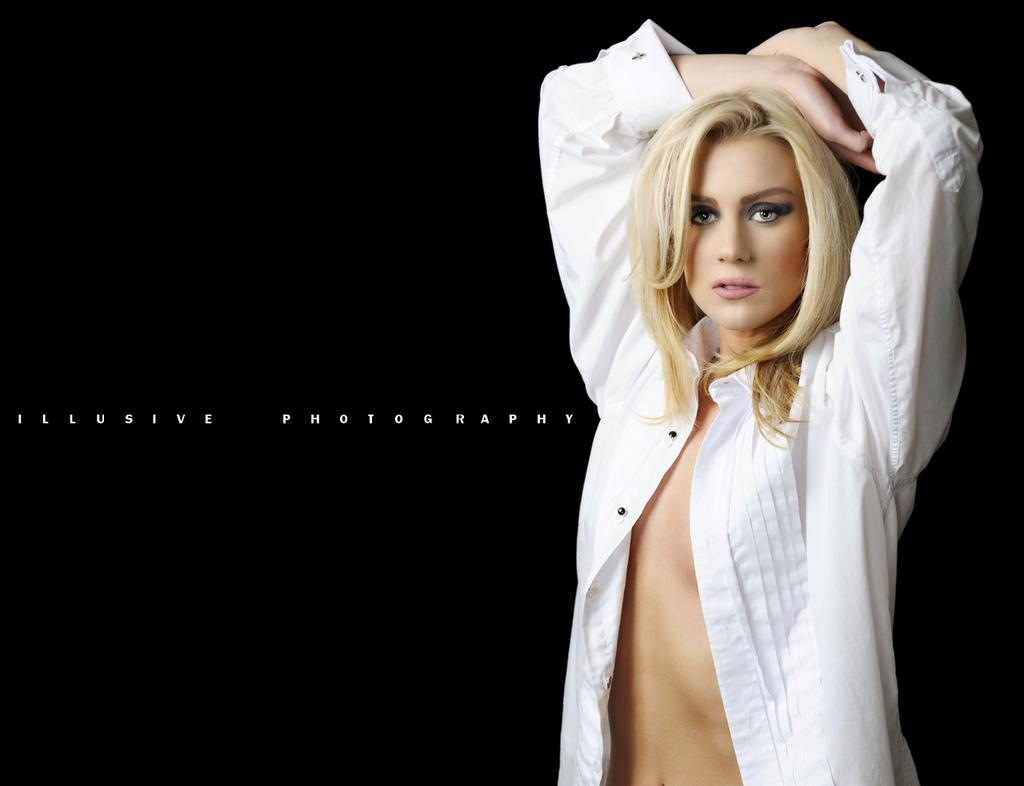What is the main subject of the image? There is a woman standing in the image. Can you describe the background of the image? The background of the image is dark. Is there any additional information about the image itself? Yes, there is a watermark on the image. What type of protest is the woman participating in the image? There is no protest visible in the image; it only shows a woman standing with a dark background. What is the condition of the woman's slavery in the image? There is no indication of slavery or any related condition in the image; it only shows a woman standing. 